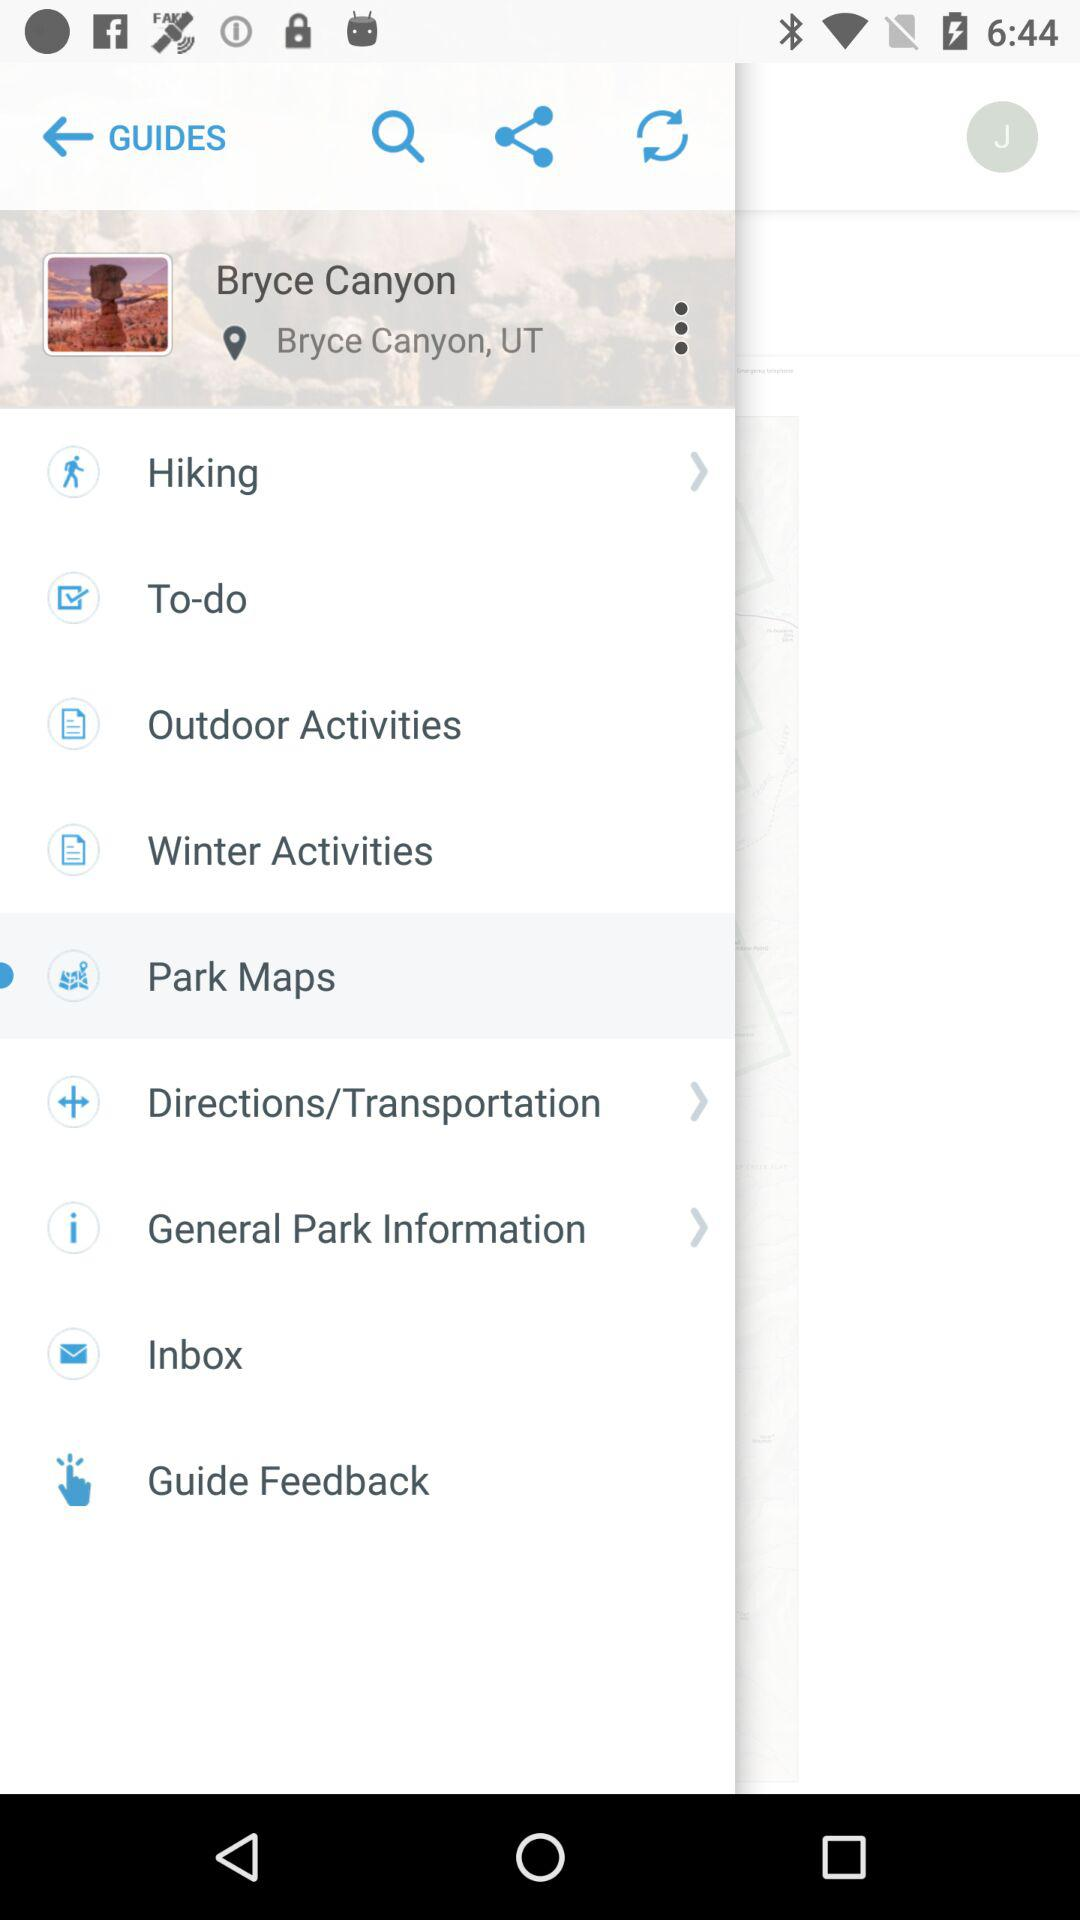Which item has been selected in the menu? The selected item is "Park Maps". 